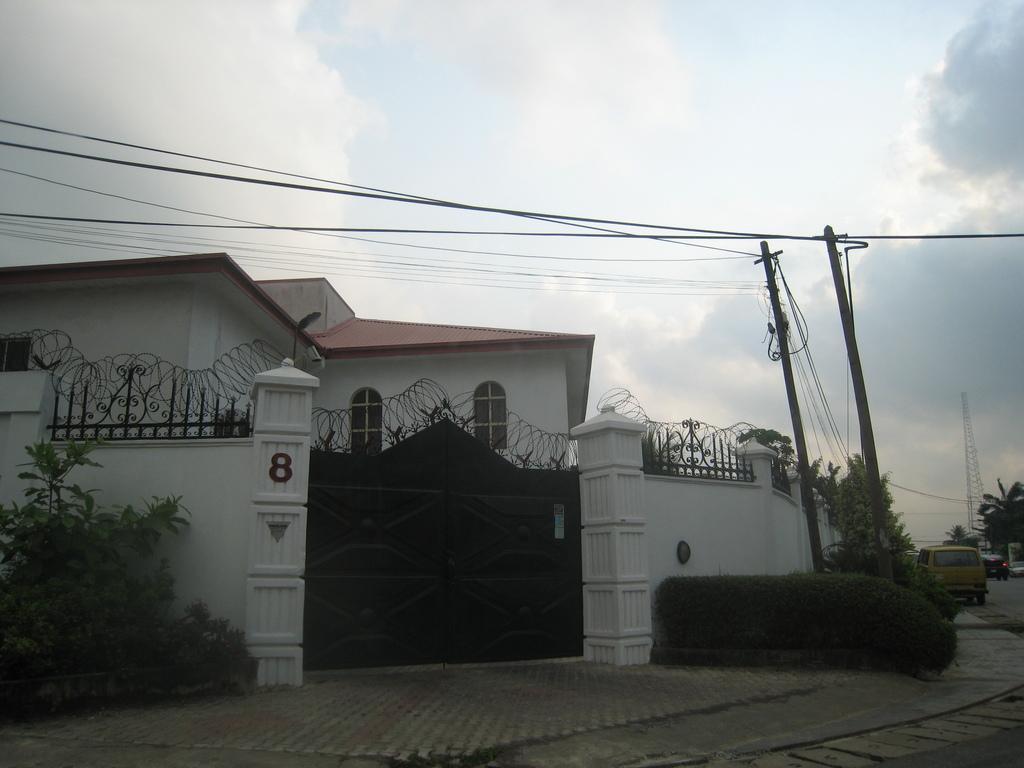How would you summarize this image in a sentence or two? In this image I can see the building, windows, gate, trees, current poles, wires, tower and few vehicles on the road. I can see the sky. 